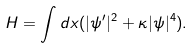<formula> <loc_0><loc_0><loc_500><loc_500>H = \int d x ( | \psi ^ { \prime } | ^ { 2 } + \kappa | \psi | ^ { 4 } ) .</formula> 